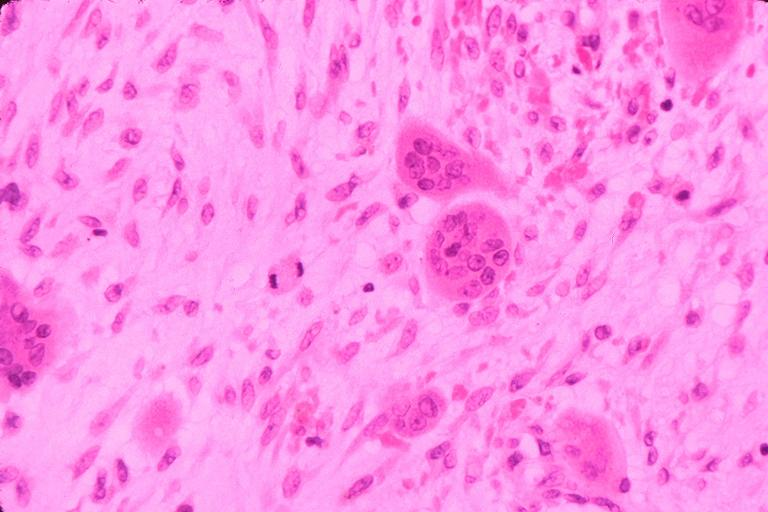s cystadenocarcinoma malignancy present?
Answer the question using a single word or phrase. No 